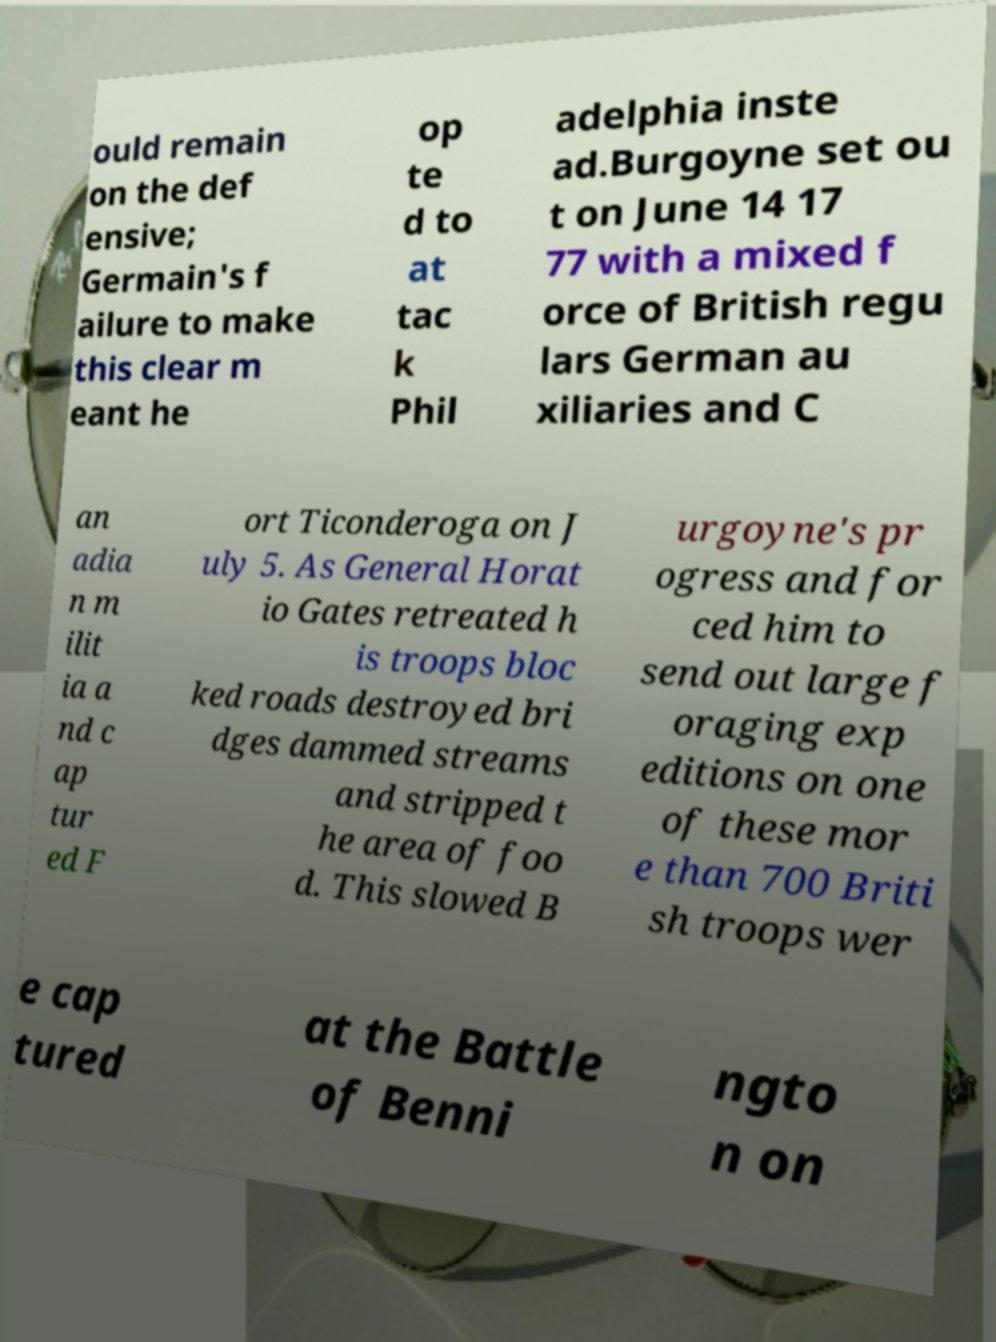Could you extract and type out the text from this image? ould remain on the def ensive; Germain's f ailure to make this clear m eant he op te d to at tac k Phil adelphia inste ad.Burgoyne set ou t on June 14 17 77 with a mixed f orce of British regu lars German au xiliaries and C an adia n m ilit ia a nd c ap tur ed F ort Ticonderoga on J uly 5. As General Horat io Gates retreated h is troops bloc ked roads destroyed bri dges dammed streams and stripped t he area of foo d. This slowed B urgoyne's pr ogress and for ced him to send out large f oraging exp editions on one of these mor e than 700 Briti sh troops wer e cap tured at the Battle of Benni ngto n on 